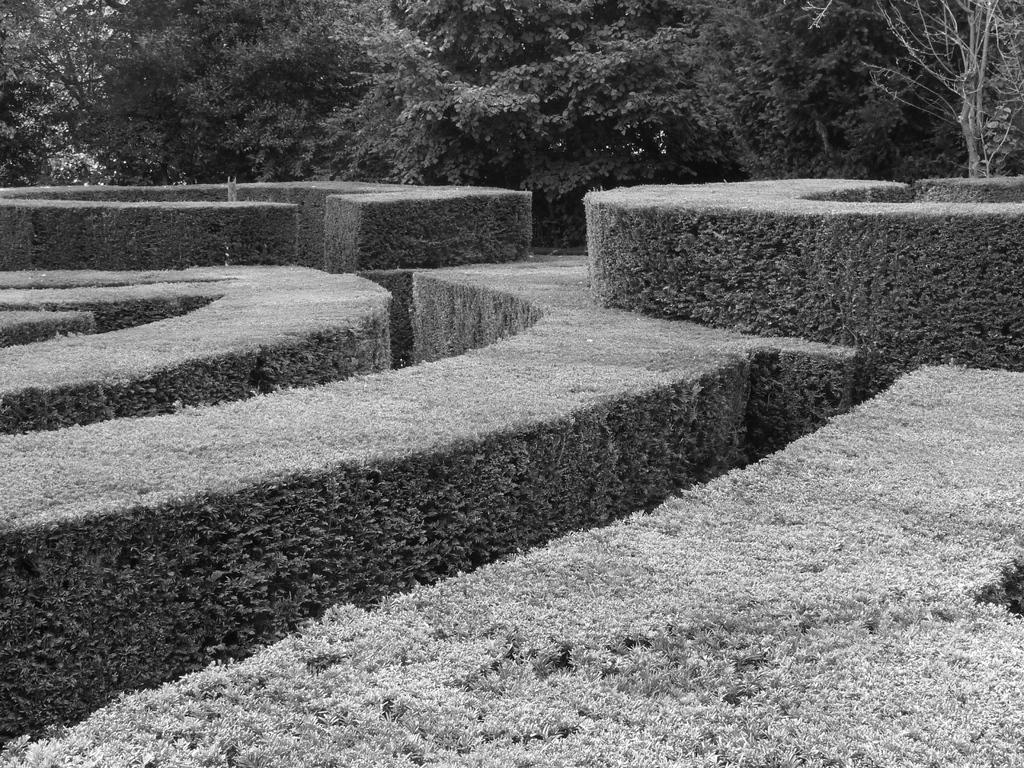What type of area is depicted in the image? There is a garden in the image. How are the plants arranged in the garden? The plants are arranged on the ground in the garden. What can be seen in the background of the image? There are trees in the background of the image. Where is the vase placed in the image? There is no vase present in the image. What type of cake is being served in the garden? There is no cake present in the image. 